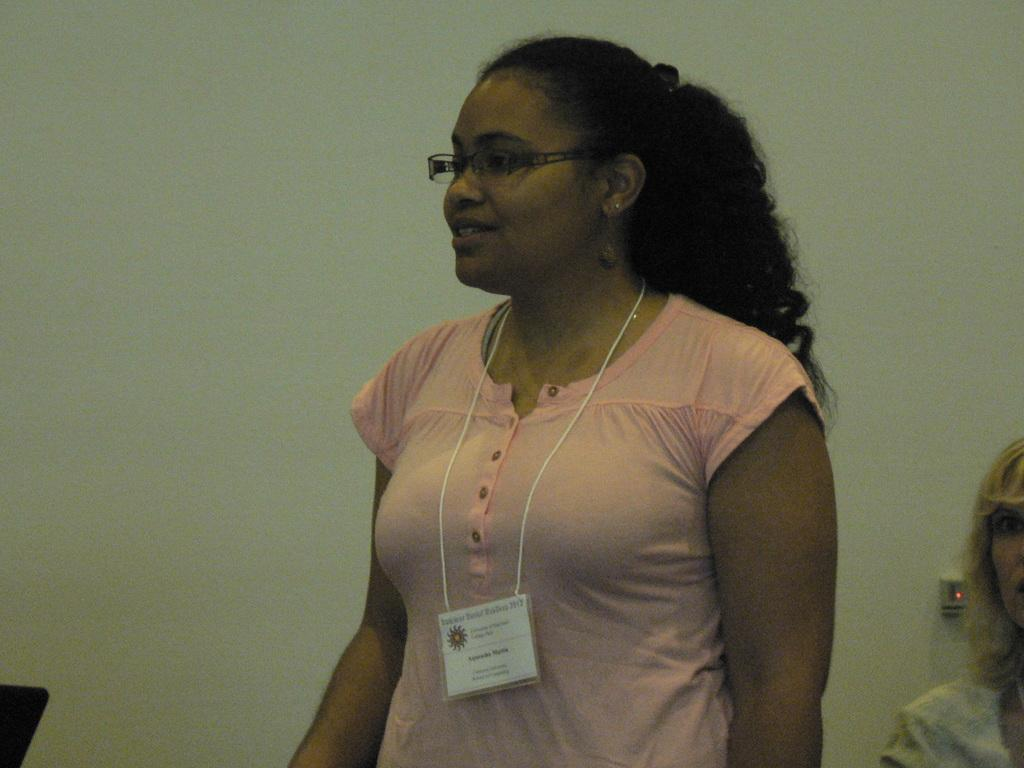What is the main subject of the image? There is a girl standing in the image. What is the girl in the image doing? The girl is looking to the left of the image. Are there any other people in the image? Yes, there is another girl beside the first girl. What can be seen in the background of the image? There is a wall in the background of the image. What type of net can be seen in the image? There is no net present in the image. What sound does the horn make in the image? There is no horn present in the image. 